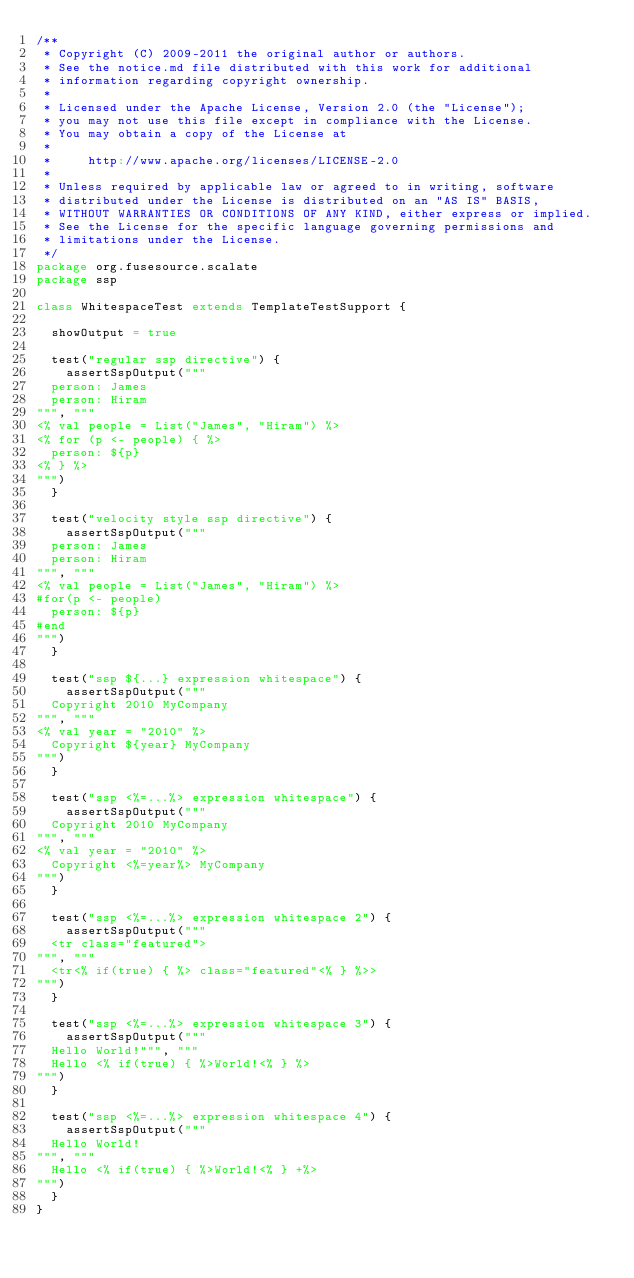Convert code to text. <code><loc_0><loc_0><loc_500><loc_500><_Scala_>/**
 * Copyright (C) 2009-2011 the original author or authors.
 * See the notice.md file distributed with this work for additional
 * information regarding copyright ownership.
 *
 * Licensed under the Apache License, Version 2.0 (the "License");
 * you may not use this file except in compliance with the License.
 * You may obtain a copy of the License at
 *
 *     http://www.apache.org/licenses/LICENSE-2.0
 *
 * Unless required by applicable law or agreed to in writing, software
 * distributed under the License is distributed on an "AS IS" BASIS,
 * WITHOUT WARRANTIES OR CONDITIONS OF ANY KIND, either express or implied.
 * See the License for the specific language governing permissions and
 * limitations under the License.
 */
package org.fusesource.scalate
package ssp

class WhitespaceTest extends TemplateTestSupport {

  showOutput = true

  test("regular ssp directive") {
    assertSspOutput("""
  person: James
  person: Hiram
""", """
<% val people = List("James", "Hiram") %>
<% for (p <- people) { %>
  person: ${p}
<% } %>
""")
  }

  test("velocity style ssp directive") {
    assertSspOutput("""
  person: James
  person: Hiram
""", """
<% val people = List("James", "Hiram") %>
#for(p <- people)
  person: ${p}
#end
""")
  }

  test("ssp ${...} expression whitespace") {
    assertSspOutput("""
  Copyright 2010 MyCompany
""", """
<% val year = "2010" %>
  Copyright ${year} MyCompany
""")
  }

  test("ssp <%=...%> expression whitespace") {
    assertSspOutput("""
  Copyright 2010 MyCompany
""", """
<% val year = "2010" %>
  Copyright <%=year%> MyCompany
""")
  }

  test("ssp <%=...%> expression whitespace 2") {
    assertSspOutput("""
  <tr class="featured">
""", """
  <tr<% if(true) { %> class="featured"<% } %>>
""")
  }

  test("ssp <%=...%> expression whitespace 3") {
    assertSspOutput("""
  Hello World!""", """
  Hello <% if(true) { %>World!<% } %>
""")
  }

  test("ssp <%=...%> expression whitespace 4") {
    assertSspOutput("""
  Hello World!
""", """
  Hello <% if(true) { %>World!<% } +%>
""")
  }
}</code> 